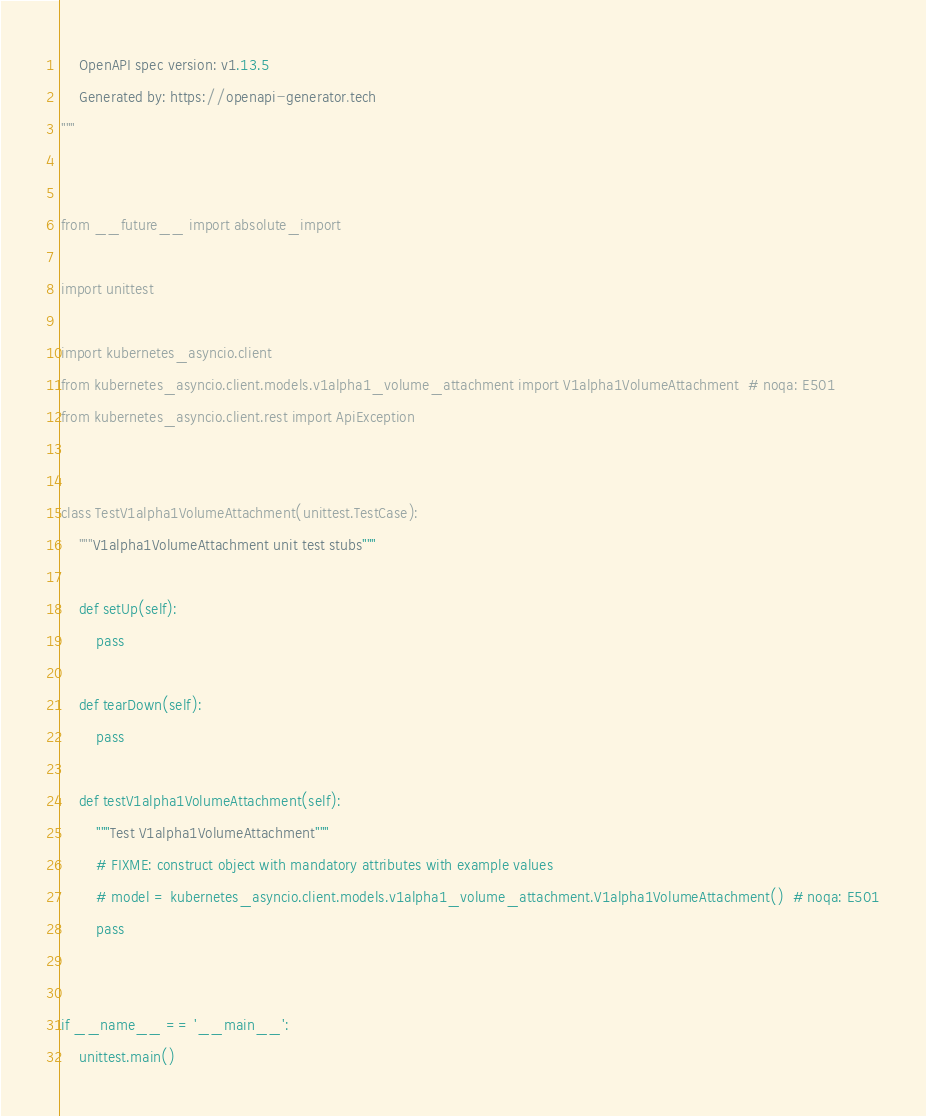Convert code to text. <code><loc_0><loc_0><loc_500><loc_500><_Python_>    OpenAPI spec version: v1.13.5
    Generated by: https://openapi-generator.tech
"""


from __future__ import absolute_import

import unittest

import kubernetes_asyncio.client
from kubernetes_asyncio.client.models.v1alpha1_volume_attachment import V1alpha1VolumeAttachment  # noqa: E501
from kubernetes_asyncio.client.rest import ApiException


class TestV1alpha1VolumeAttachment(unittest.TestCase):
    """V1alpha1VolumeAttachment unit test stubs"""

    def setUp(self):
        pass

    def tearDown(self):
        pass

    def testV1alpha1VolumeAttachment(self):
        """Test V1alpha1VolumeAttachment"""
        # FIXME: construct object with mandatory attributes with example values
        # model = kubernetes_asyncio.client.models.v1alpha1_volume_attachment.V1alpha1VolumeAttachment()  # noqa: E501
        pass


if __name__ == '__main__':
    unittest.main()
</code> 